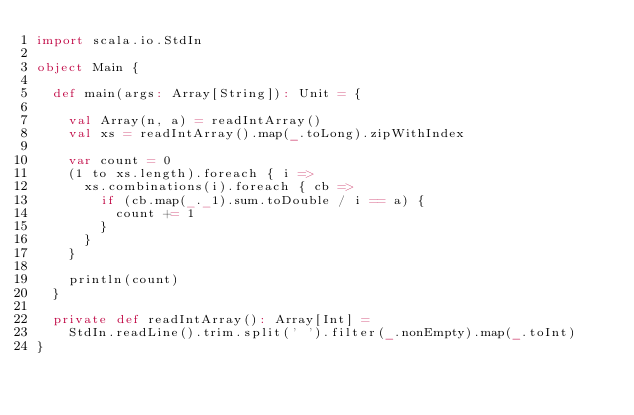Convert code to text. <code><loc_0><loc_0><loc_500><loc_500><_Scala_>import scala.io.StdIn

object Main {

  def main(args: Array[String]): Unit = {

    val Array(n, a) = readIntArray()
    val xs = readIntArray().map(_.toLong).zipWithIndex

    var count = 0
    (1 to xs.length).foreach { i =>
      xs.combinations(i).foreach { cb =>
        if (cb.map(_._1).sum.toDouble / i == a) {
          count += 1
        }
      }
    }

    println(count)
  }

  private def readIntArray(): Array[Int] =
    StdIn.readLine().trim.split(' ').filter(_.nonEmpty).map(_.toInt)
}
</code> 